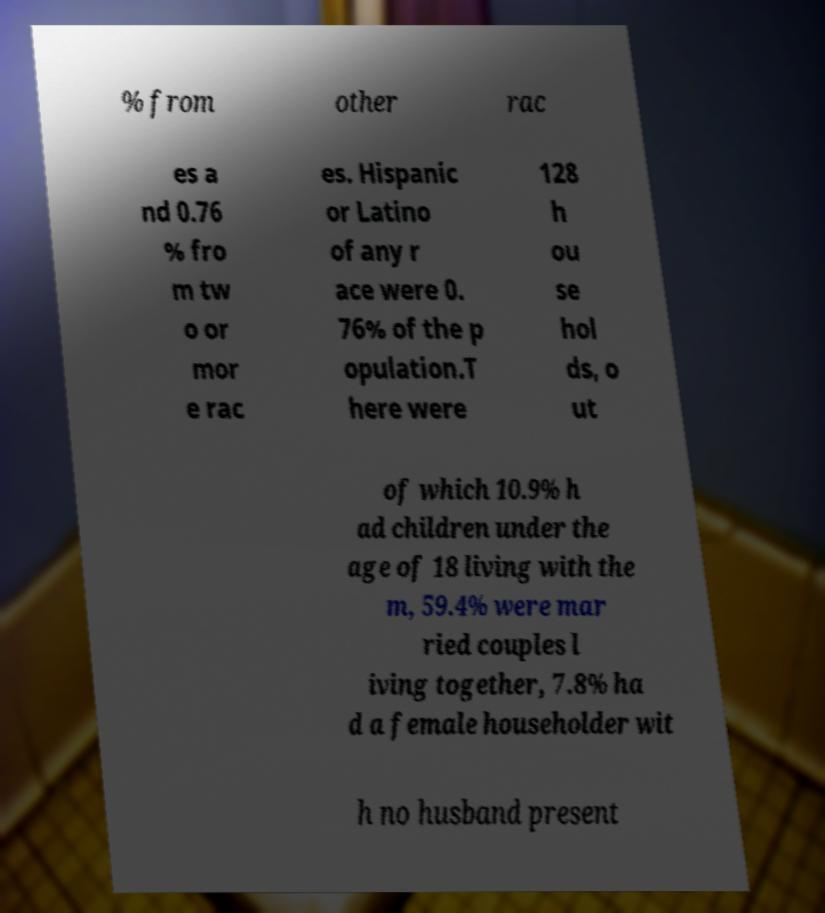For documentation purposes, I need the text within this image transcribed. Could you provide that? % from other rac es a nd 0.76 % fro m tw o or mor e rac es. Hispanic or Latino of any r ace were 0. 76% of the p opulation.T here were 128 h ou se hol ds, o ut of which 10.9% h ad children under the age of 18 living with the m, 59.4% were mar ried couples l iving together, 7.8% ha d a female householder wit h no husband present 